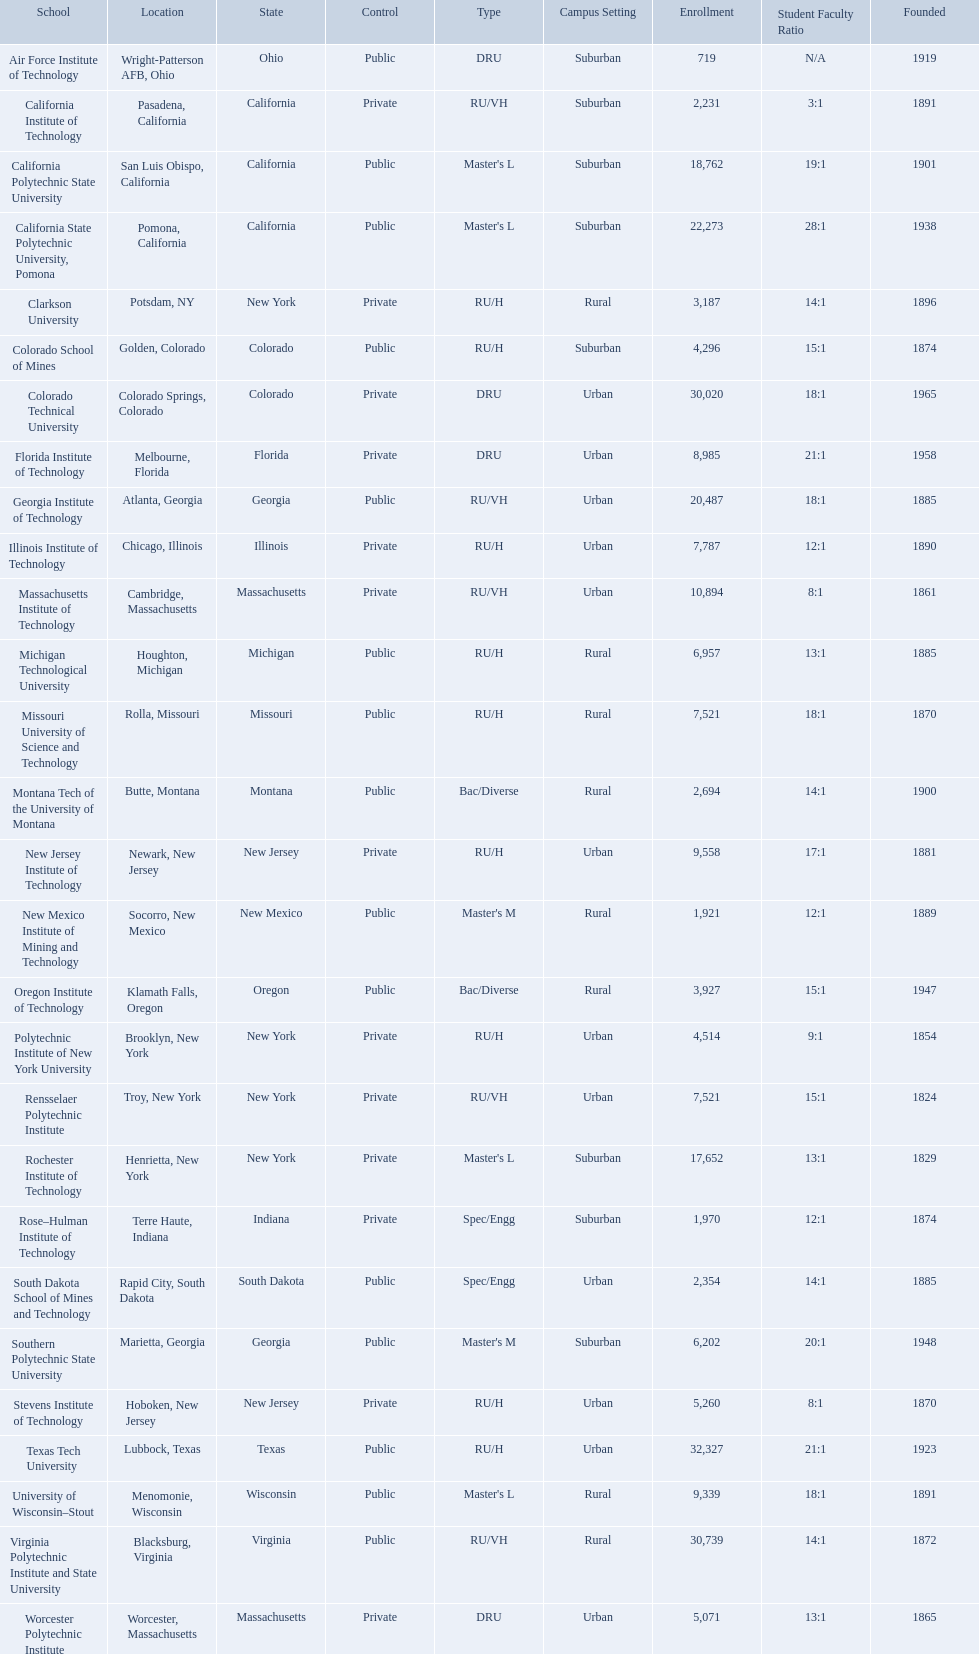What are the listed enrollment numbers of us universities? 719, 2,231, 18,762, 22,273, 3,187, 4,296, 30,020, 8,985, 20,487, 7,787, 10,894, 6,957, 7,521, 2,694, 9,558, 1,921, 3,927, 4,514, 7,521, 17,652, 1,970, 2,354, 6,202, 5,260, 32,327, 9,339, 30,739, 5,071. Of these, which has the highest value? 32,327. What are the listed names of us universities? Air Force Institute of Technology, California Institute of Technology, California Polytechnic State University, California State Polytechnic University, Pomona, Clarkson University, Colorado School of Mines, Colorado Technical University, Florida Institute of Technology, Georgia Institute of Technology, Illinois Institute of Technology, Massachusetts Institute of Technology, Michigan Technological University, Missouri University of Science and Technology, Montana Tech of the University of Montana, New Jersey Institute of Technology, New Mexico Institute of Mining and Technology, Oregon Institute of Technology, Polytechnic Institute of New York University, Rensselaer Polytechnic Institute, Rochester Institute of Technology, Rose–Hulman Institute of Technology, South Dakota School of Mines and Technology, Southern Polytechnic State University, Stevens Institute of Technology, Texas Tech University, University of Wisconsin–Stout, Virginia Polytechnic Institute and State University, Worcester Polytechnic Institute. Which of these correspond to the previously listed highest enrollment value? Texas Tech University. What technical universities are in the united states? Air Force Institute of Technology, California Institute of Technology, California Polytechnic State University, California State Polytechnic University, Pomona, Clarkson University, Colorado School of Mines, Colorado Technical University, Florida Institute of Technology, Georgia Institute of Technology, Illinois Institute of Technology, Massachusetts Institute of Technology, Michigan Technological University, Missouri University of Science and Technology, Montana Tech of the University of Montana, New Jersey Institute of Technology, New Mexico Institute of Mining and Technology, Oregon Institute of Technology, Polytechnic Institute of New York University, Rensselaer Polytechnic Institute, Rochester Institute of Technology, Rose–Hulman Institute of Technology, South Dakota School of Mines and Technology, Southern Polytechnic State University, Stevens Institute of Technology, Texas Tech University, University of Wisconsin–Stout, Virginia Polytechnic Institute and State University, Worcester Polytechnic Institute. Which has the highest enrollment? Texas Tech University. What are all the schools? Air Force Institute of Technology, California Institute of Technology, California Polytechnic State University, California State Polytechnic University, Pomona, Clarkson University, Colorado School of Mines, Colorado Technical University, Florida Institute of Technology, Georgia Institute of Technology, Illinois Institute of Technology, Massachusetts Institute of Technology, Michigan Technological University, Missouri University of Science and Technology, Montana Tech of the University of Montana, New Jersey Institute of Technology, New Mexico Institute of Mining and Technology, Oregon Institute of Technology, Polytechnic Institute of New York University, Rensselaer Polytechnic Institute, Rochester Institute of Technology, Rose–Hulman Institute of Technology, South Dakota School of Mines and Technology, Southern Polytechnic State University, Stevens Institute of Technology, Texas Tech University, University of Wisconsin–Stout, Virginia Polytechnic Institute and State University, Worcester Polytechnic Institute. What is the enrollment of each school? 719, 2,231, 18,762, 22,273, 3,187, 4,296, 30,020, 8,985, 20,487, 7,787, 10,894, 6,957, 7,521, 2,694, 9,558, 1,921, 3,927, 4,514, 7,521, 17,652, 1,970, 2,354, 6,202, 5,260, 32,327, 9,339, 30,739, 5,071. And which school had the highest enrollment? Texas Tech University. 